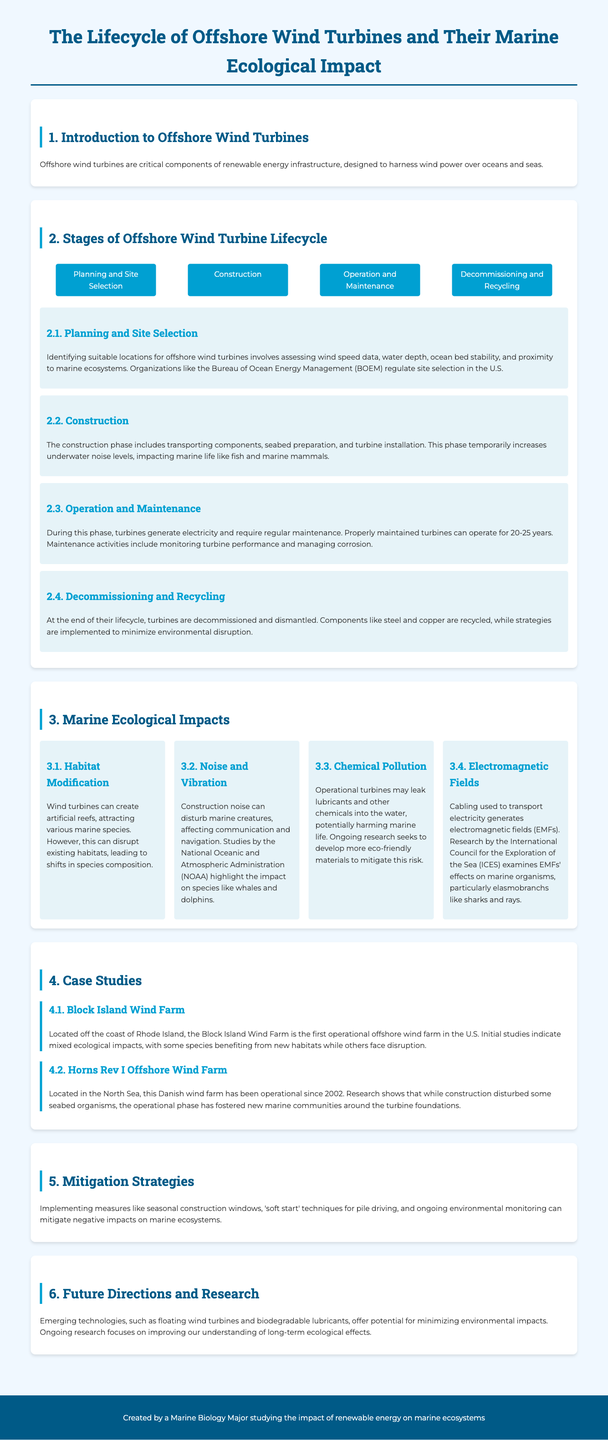what is the first stage of the offshore wind turbine lifecycle? The first stage involves identifying suitable locations and assessing various factors relevant to site selection.
Answer: Planning and Site Selection how many years can a properly maintained turbine operate? The document states that properly maintained turbines can have a lifespan of 20-25 years.
Answer: 20-25 years what is one potential impact of construction noise on marine life? The construction noise can disturb marine creatures, affecting their communication and navigation.
Answer: Disturb communication which organization regulates site selection in the U.S.? The organization mentioned in the document that regulates site selection is the Bureau of Ocean Energy Management.
Answer: Bureau of Ocean Energy Management what is the objective of implementing seasonal construction windows? Seasonal construction windows aim to mitigate negative impacts on marine ecosystems during specific times of year.
Answer: Mitigate negative impacts what type of contamination might occur due to operational turbines? Operational turbines may lead to chemical pollution through leakage of lubricants and other chemicals into the water.
Answer: Chemical pollution how did the Horns Rev I Offshore Wind Farm impact marine communities? The wind farm's operational phase has fostered new marine communities around the turbine foundations despite initial disturbances.
Answer: Fostered new marine communities what type of new technologies are being researched for offshore wind turbines? Emerging technologies such as floating wind turbines and biodegradable lubricants are being researched.
Answer: Floating wind turbines which two marine species groups are particularly affected by electromagnetic fields? The document points out that elasmobranchs, like sharks and rays, are particularly affected by electromagnetic fields.
Answer: Sharks and rays 